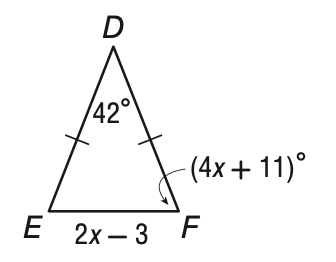Answer the mathemtical geometry problem and directly provide the correct option letter.
Question: What is the length of E F?
Choices: A: 13 B: 14.5 C: 26 D: 29 C 